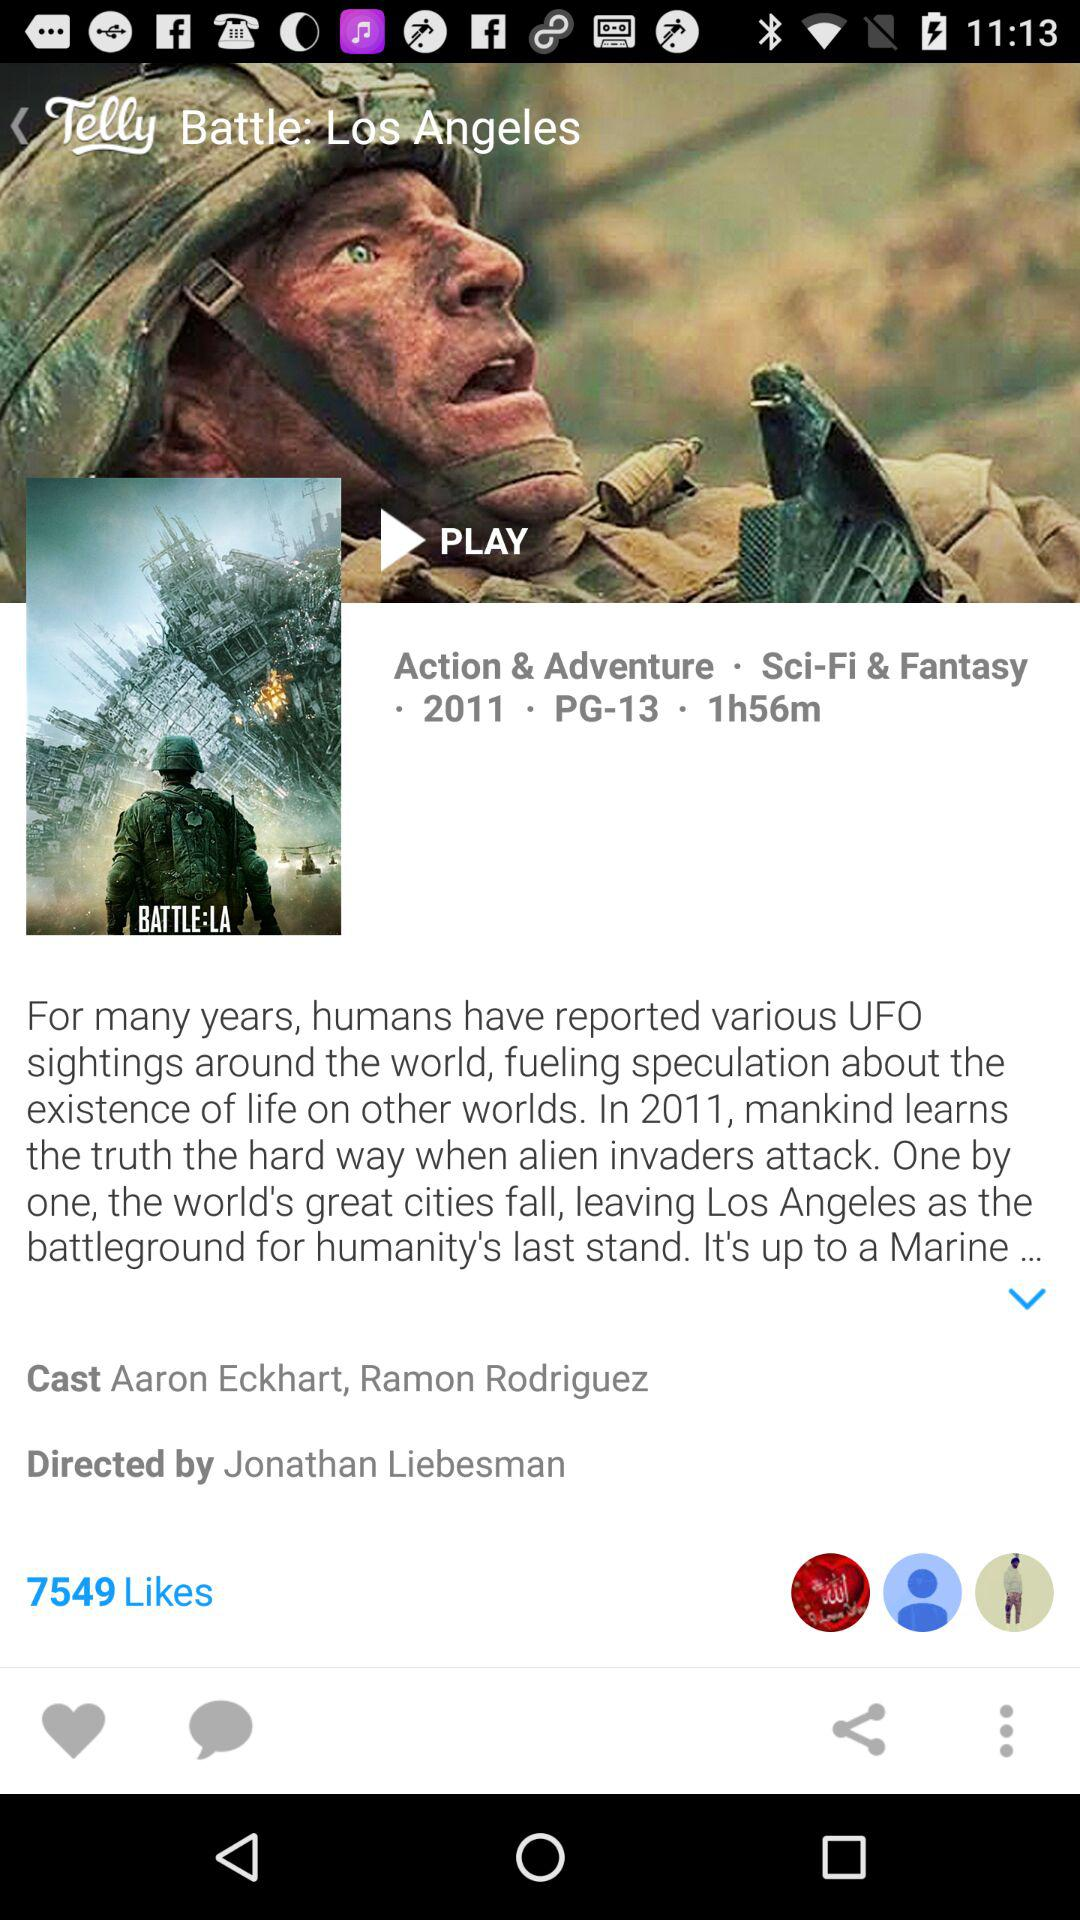Who is the director? The director is Jonathan Liebesman. 